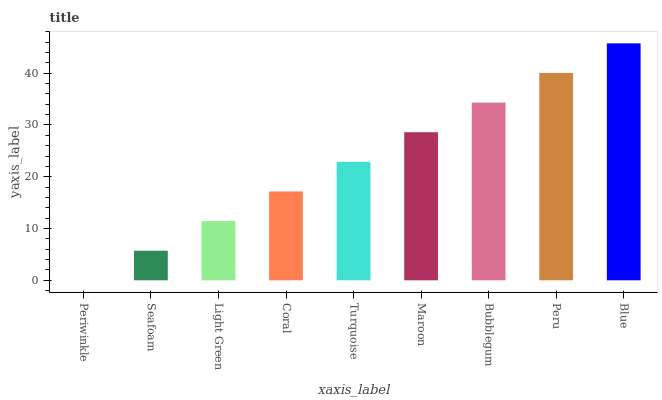Is Seafoam the minimum?
Answer yes or no. No. Is Seafoam the maximum?
Answer yes or no. No. Is Seafoam greater than Periwinkle?
Answer yes or no. Yes. Is Periwinkle less than Seafoam?
Answer yes or no. Yes. Is Periwinkle greater than Seafoam?
Answer yes or no. No. Is Seafoam less than Periwinkle?
Answer yes or no. No. Is Turquoise the high median?
Answer yes or no. Yes. Is Turquoise the low median?
Answer yes or no. Yes. Is Bubblegum the high median?
Answer yes or no. No. Is Periwinkle the low median?
Answer yes or no. No. 